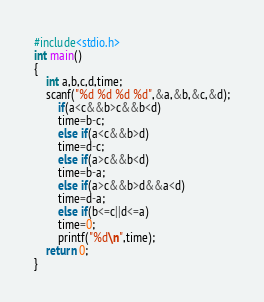<code> <loc_0><loc_0><loc_500><loc_500><_C_>#include<stdio.h>
int main()
{
	int a,b,c,d,time;
	scanf("%d %d %d %d",&a,&b,&c,&d);
		if(a<c&&b>c&&b<d)
	    time=b-c;
		else if(a<c&&b>d)
		time=d-c;
		else if(a>c&&b<d)
		time=b-a;
		else if(a>c&&b>d&&a<d)
		time=d-a;
		else if(b<=c||d<=a)
		time=0;
		printf("%d\n",time);
	return 0;
}</code> 